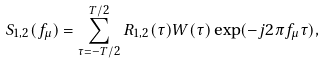<formula> <loc_0><loc_0><loc_500><loc_500>S _ { 1 , 2 } ( f _ { \mu } ) = \sum _ { \tau = - T / 2 } ^ { T / 2 } R _ { 1 , 2 } ( \tau ) W ( \tau ) \exp ( - j 2 \pi f _ { \mu } \tau ) ,</formula> 